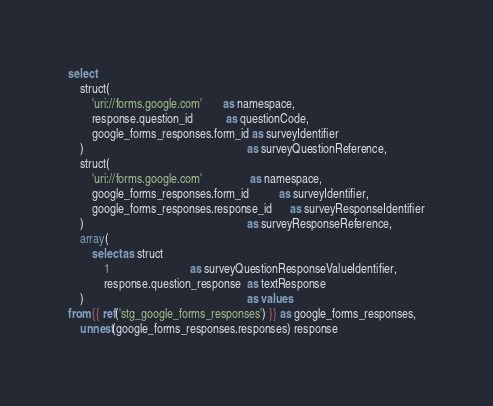Convert code to text. <code><loc_0><loc_0><loc_500><loc_500><_SQL_>
select
    struct(
        'uri://forms.google.com'       as namespace,
        response.question_id           as questionCode,
        google_forms_responses.form_id as surveyIdentifier
    )                                                       as surveyQuestionReference,
    struct(
        'uri://forms.google.com'                as namespace,
        google_forms_responses.form_id          as surveyIdentifier,
        google_forms_responses.response_id      as surveyResponseIdentifier
    )                                                       as surveyResponseReference,
    array(
        select as struct
            1                           as surveyQuestionResponseValueIdentifier,
            response.question_response  as textResponse
    )                                                       as values
from {{ ref('stg_google_forms_responses') }} as google_forms_responses,
    unnest(google_forms_responses.responses) response
</code> 